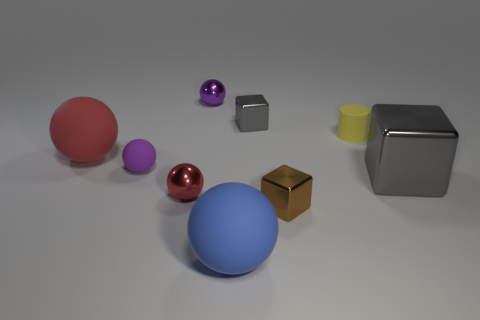Subtract 1 balls. How many balls are left? 4 Subtract all tiny red balls. How many balls are left? 4 Subtract all blue spheres. How many spheres are left? 4 Subtract all cyan balls. Subtract all blue cylinders. How many balls are left? 5 Add 1 large rubber spheres. How many objects exist? 10 Subtract all cubes. How many objects are left? 6 Add 6 tiny balls. How many tiny balls exist? 9 Subtract 0 yellow blocks. How many objects are left? 9 Subtract all small green matte cylinders. Subtract all small yellow rubber objects. How many objects are left? 8 Add 3 gray blocks. How many gray blocks are left? 5 